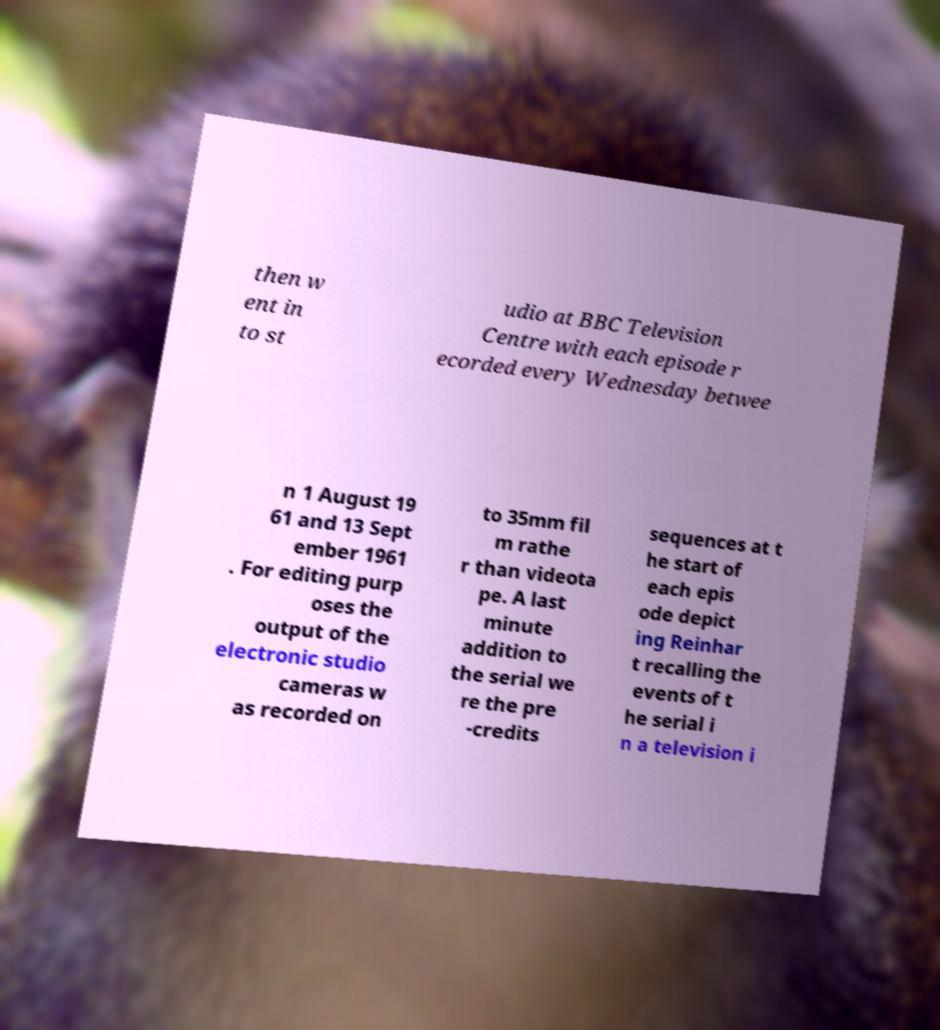Please identify and transcribe the text found in this image. then w ent in to st udio at BBC Television Centre with each episode r ecorded every Wednesday betwee n 1 August 19 61 and 13 Sept ember 1961 . For editing purp oses the output of the electronic studio cameras w as recorded on to 35mm fil m rathe r than videota pe. A last minute addition to the serial we re the pre -credits sequences at t he start of each epis ode depict ing Reinhar t recalling the events of t he serial i n a television i 